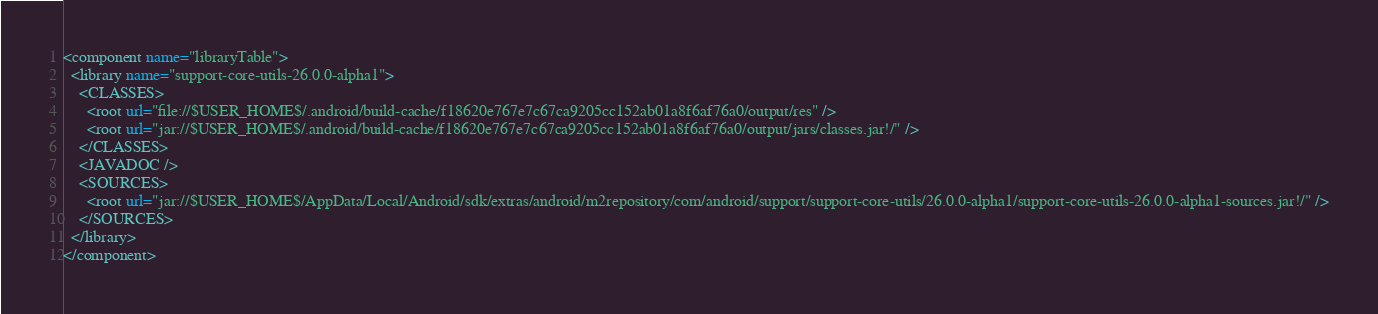Convert code to text. <code><loc_0><loc_0><loc_500><loc_500><_XML_><component name="libraryTable">
  <library name="support-core-utils-26.0.0-alpha1">
    <CLASSES>
      <root url="file://$USER_HOME$/.android/build-cache/f18620e767e7c67ca9205cc152ab01a8f6af76a0/output/res" />
      <root url="jar://$USER_HOME$/.android/build-cache/f18620e767e7c67ca9205cc152ab01a8f6af76a0/output/jars/classes.jar!/" />
    </CLASSES>
    <JAVADOC />
    <SOURCES>
      <root url="jar://$USER_HOME$/AppData/Local/Android/sdk/extras/android/m2repository/com/android/support/support-core-utils/26.0.0-alpha1/support-core-utils-26.0.0-alpha1-sources.jar!/" />
    </SOURCES>
  </library>
</component></code> 